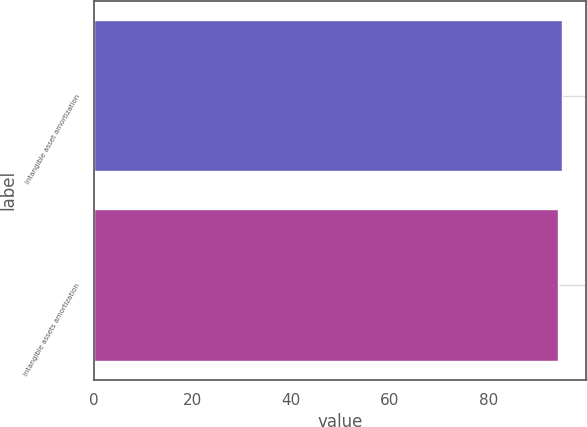Convert chart. <chart><loc_0><loc_0><loc_500><loc_500><bar_chart><fcel>Intangible asset amortization<fcel>Intangible assets amortization<nl><fcel>95<fcel>94<nl></chart> 